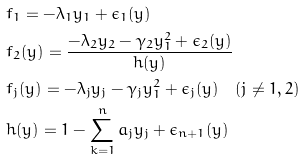<formula> <loc_0><loc_0><loc_500><loc_500>& f _ { 1 } = - \lambda _ { 1 } y _ { 1 } + \epsilon _ { 1 } ( y ) \\ & f _ { 2 } ( y ) = \frac { - \lambda _ { 2 } y _ { 2 } - \gamma _ { 2 } y _ { 1 } ^ { 2 } + \epsilon _ { 2 } ( y ) } { h ( y ) } \\ & f _ { j } ( y ) = - \lambda _ { j } y _ { j } - \gamma _ { j } y _ { 1 } ^ { 2 } + \epsilon _ { j } ( y ) \quad ( j \ne 1 , 2 ) \\ & h ( y ) = 1 - \sum _ { k = 1 } ^ { n } a _ { j } y _ { j } + \epsilon _ { n + 1 } ( y )</formula> 